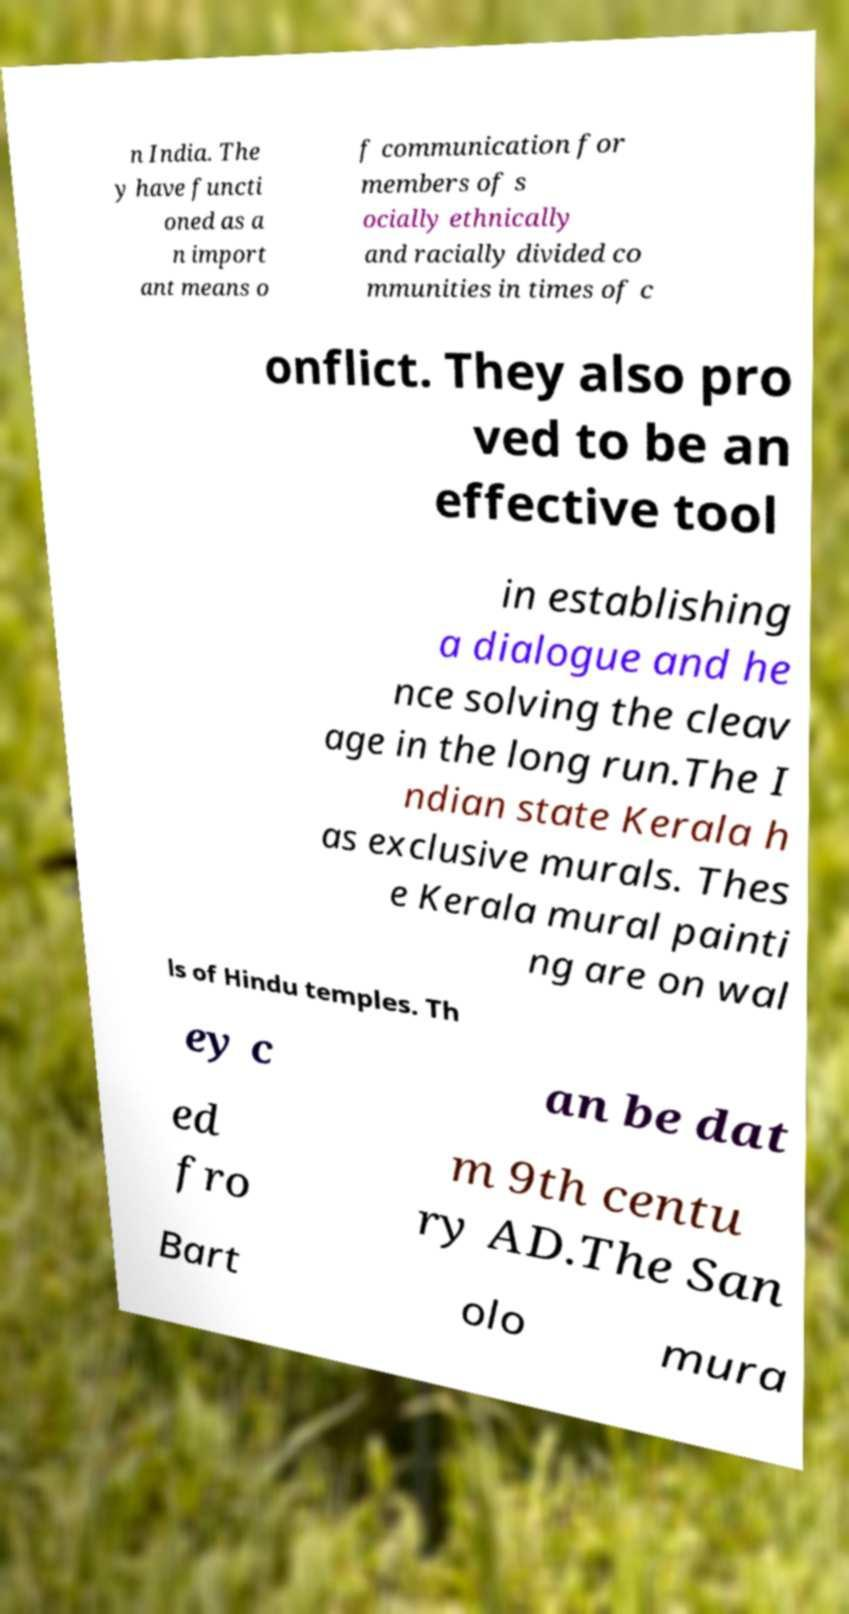Could you extract and type out the text from this image? n India. The y have functi oned as a n import ant means o f communication for members of s ocially ethnically and racially divided co mmunities in times of c onflict. They also pro ved to be an effective tool in establishing a dialogue and he nce solving the cleav age in the long run.The I ndian state Kerala h as exclusive murals. Thes e Kerala mural painti ng are on wal ls of Hindu temples. Th ey c an be dat ed fro m 9th centu ry AD.The San Bart olo mura 